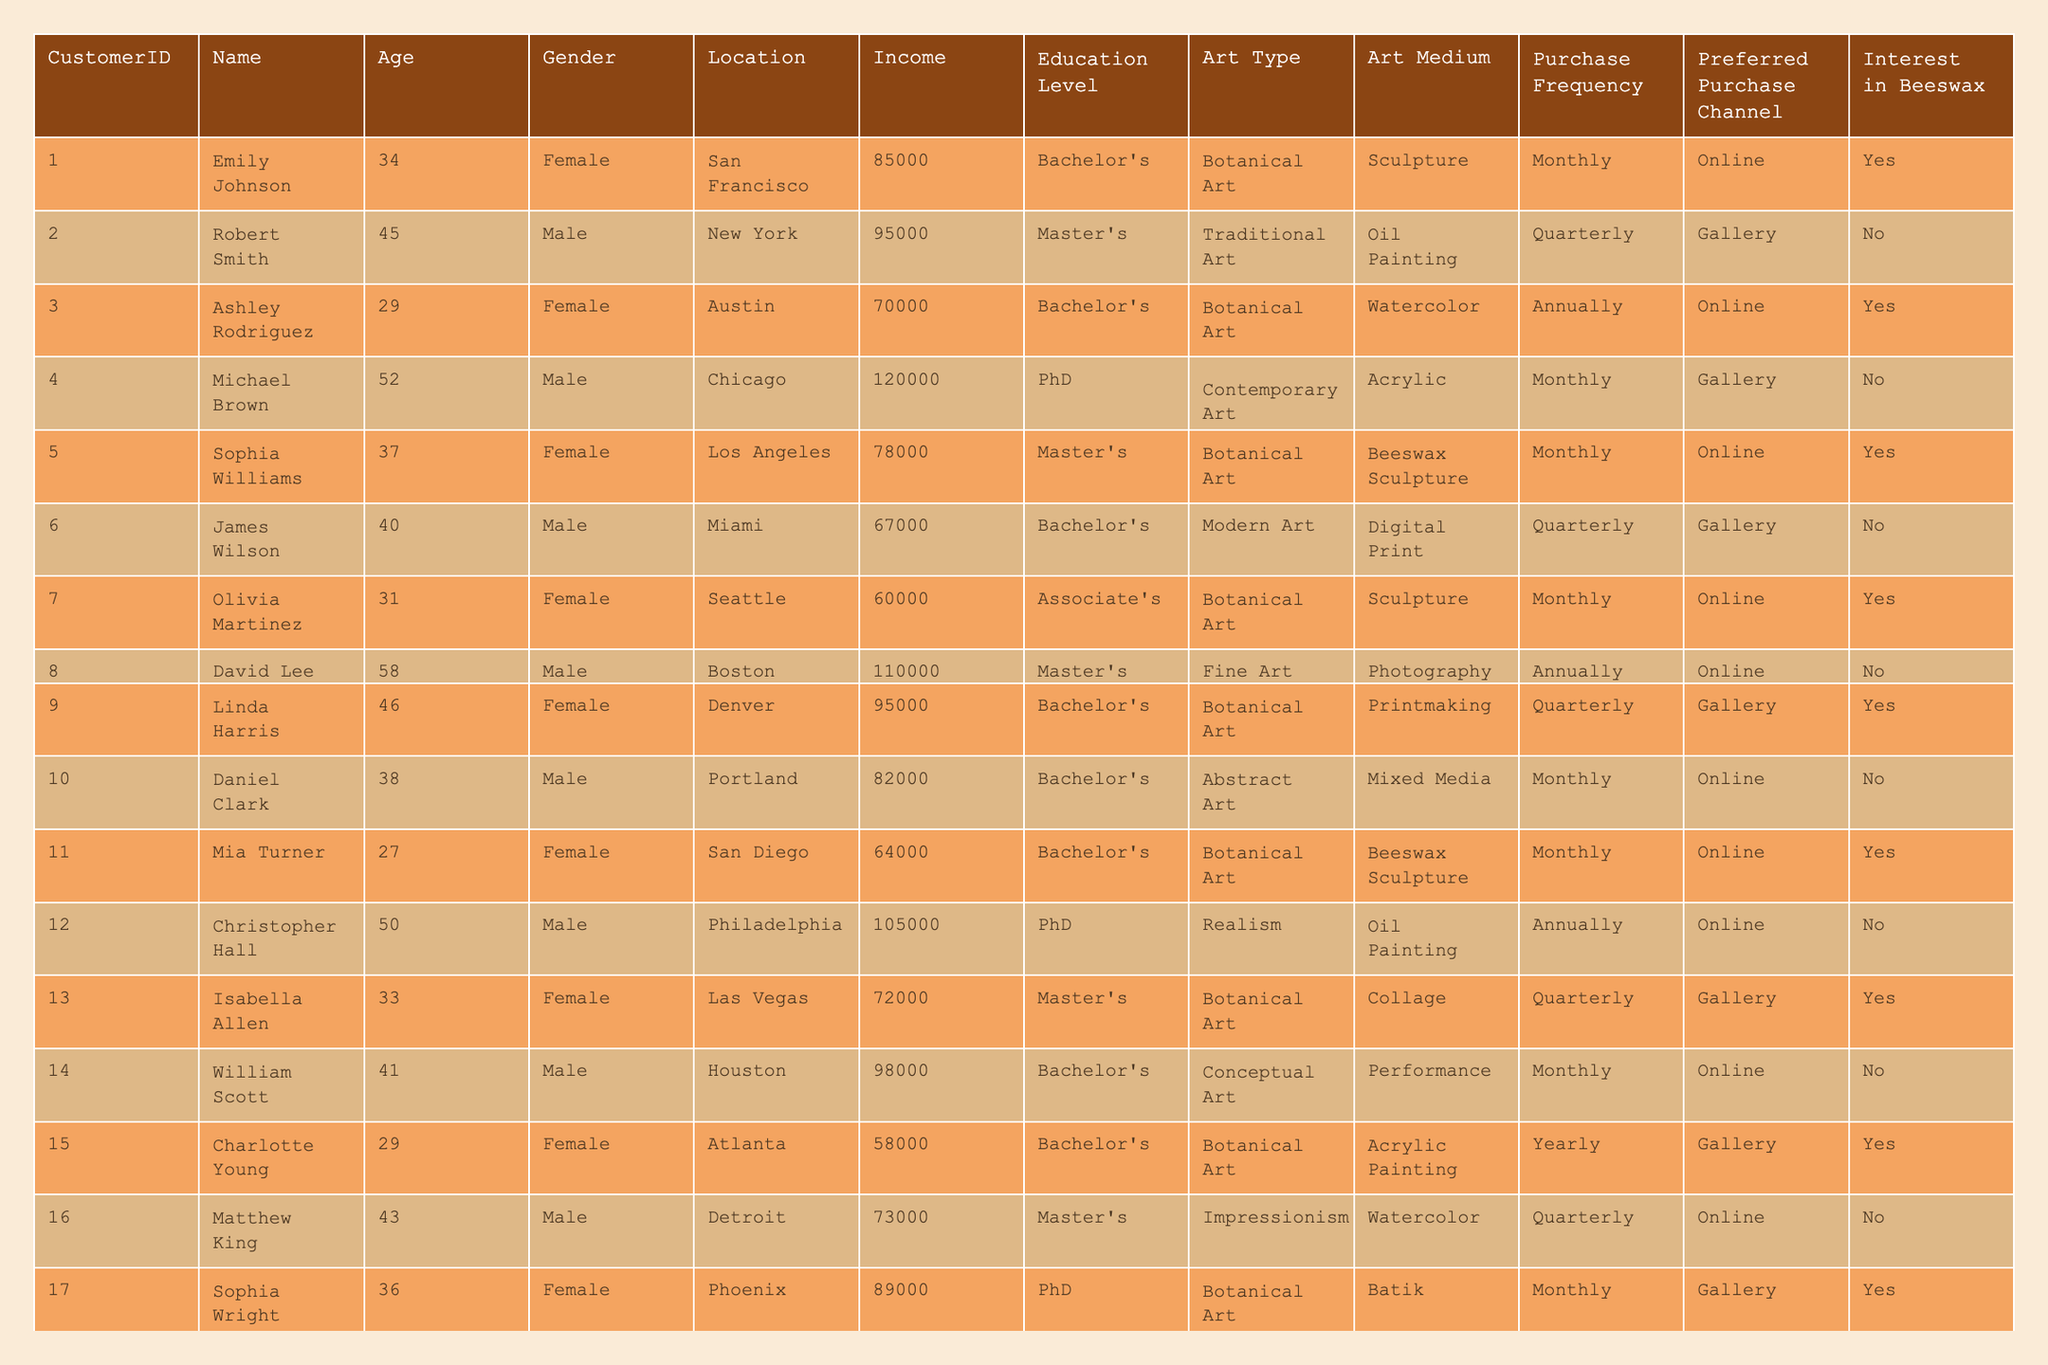What is the highest income among the customers? The highest income in the table is found by checking each customer’s income. The maximum value is 125000 associated with Henry Nelson.
Answer: 125000 How many customers have a preferred purchase channel of Gallery? By counting the instances in the "Preferred Purchase Channel" column where the channel is "Gallery", I find that there are 9 customers who prefer this channel.
Answer: 9 What percentage of customers are interested in Beeswax? To find the percentage, I count the number of customers who have "Yes" under "Interest in Beeswax" (8 customers) and divide it by the total number of customers (20), giving (8/20) * 100 = 40%.
Answer: 40% Is there any customer from San Francisco interested in Beeswax? Checking the rows for customers from San Francisco, I see that Emily Johnson is interested in Beeswax (Yes).
Answer: Yes How many females are collectors of Botanical Art? By filtering the table for 'Botanical Art' under "Art Type" and checking the "Gender" column, I find 5 females: Emily Johnson, Ashley Rodriguez, Sophia Williams, Olivia Martinez, and Isabella Allen.
Answer: 5 What is the average age of customers interested in Beeswax? To find the average age, I first identify the customers interested in Beeswax (ages: 34, 29, 37, 31, 27, 29, 36), sum these ages to get 34 + 29 + 37 + 31 + 27 + 29 + 36 =  223. Then, divide by the number of interested customers (7), resulting in an average age of 223/7 = 31.857.
Answer: 31.857 How many customers from Los Angeles and their income combined? First, I find that there is one customer from Los Angeles: Sophia Williams, with an income of 78000. Thus, the combined total for this location is simply 78000.
Answer: 78000 What is the difference in income between the oldest and youngest customers? The oldest customer is Henry Nelson with an income of 125000 and the youngest is Mia Turner with an income of 64000. The difference in their income is 125000 - 64000 = 61000.
Answer: 61000 Which customer has the highest level of education and what is their art type? Looking at the "Education Level" column, I find that the highest is "PhD," associated with multiple customers, but Christopher Hall has the highest income (105000) in this education category and their art type is "Realism."
Answer: Christopher Hall, Realism How many male customers are there that prefer online purchases? By counting the rows where "Gender" is Male and "Preferred Purchase Channel" is Online, I find three male customers: William Scott, Anthony Green, and Henry Nelson.
Answer: 3 What is the total income of customers who purchase Botanical Art monthly? Identifying the customers who buy Botanical Art monthly, I list their incomes: Emily Johnson (85000), Sophia Williams (78000), Olivia Martinez (60000), and Sophia Wright (89000). Summing this gives 85000 + 78000 + 60000 + 89000 = 312000.
Answer: 312000 